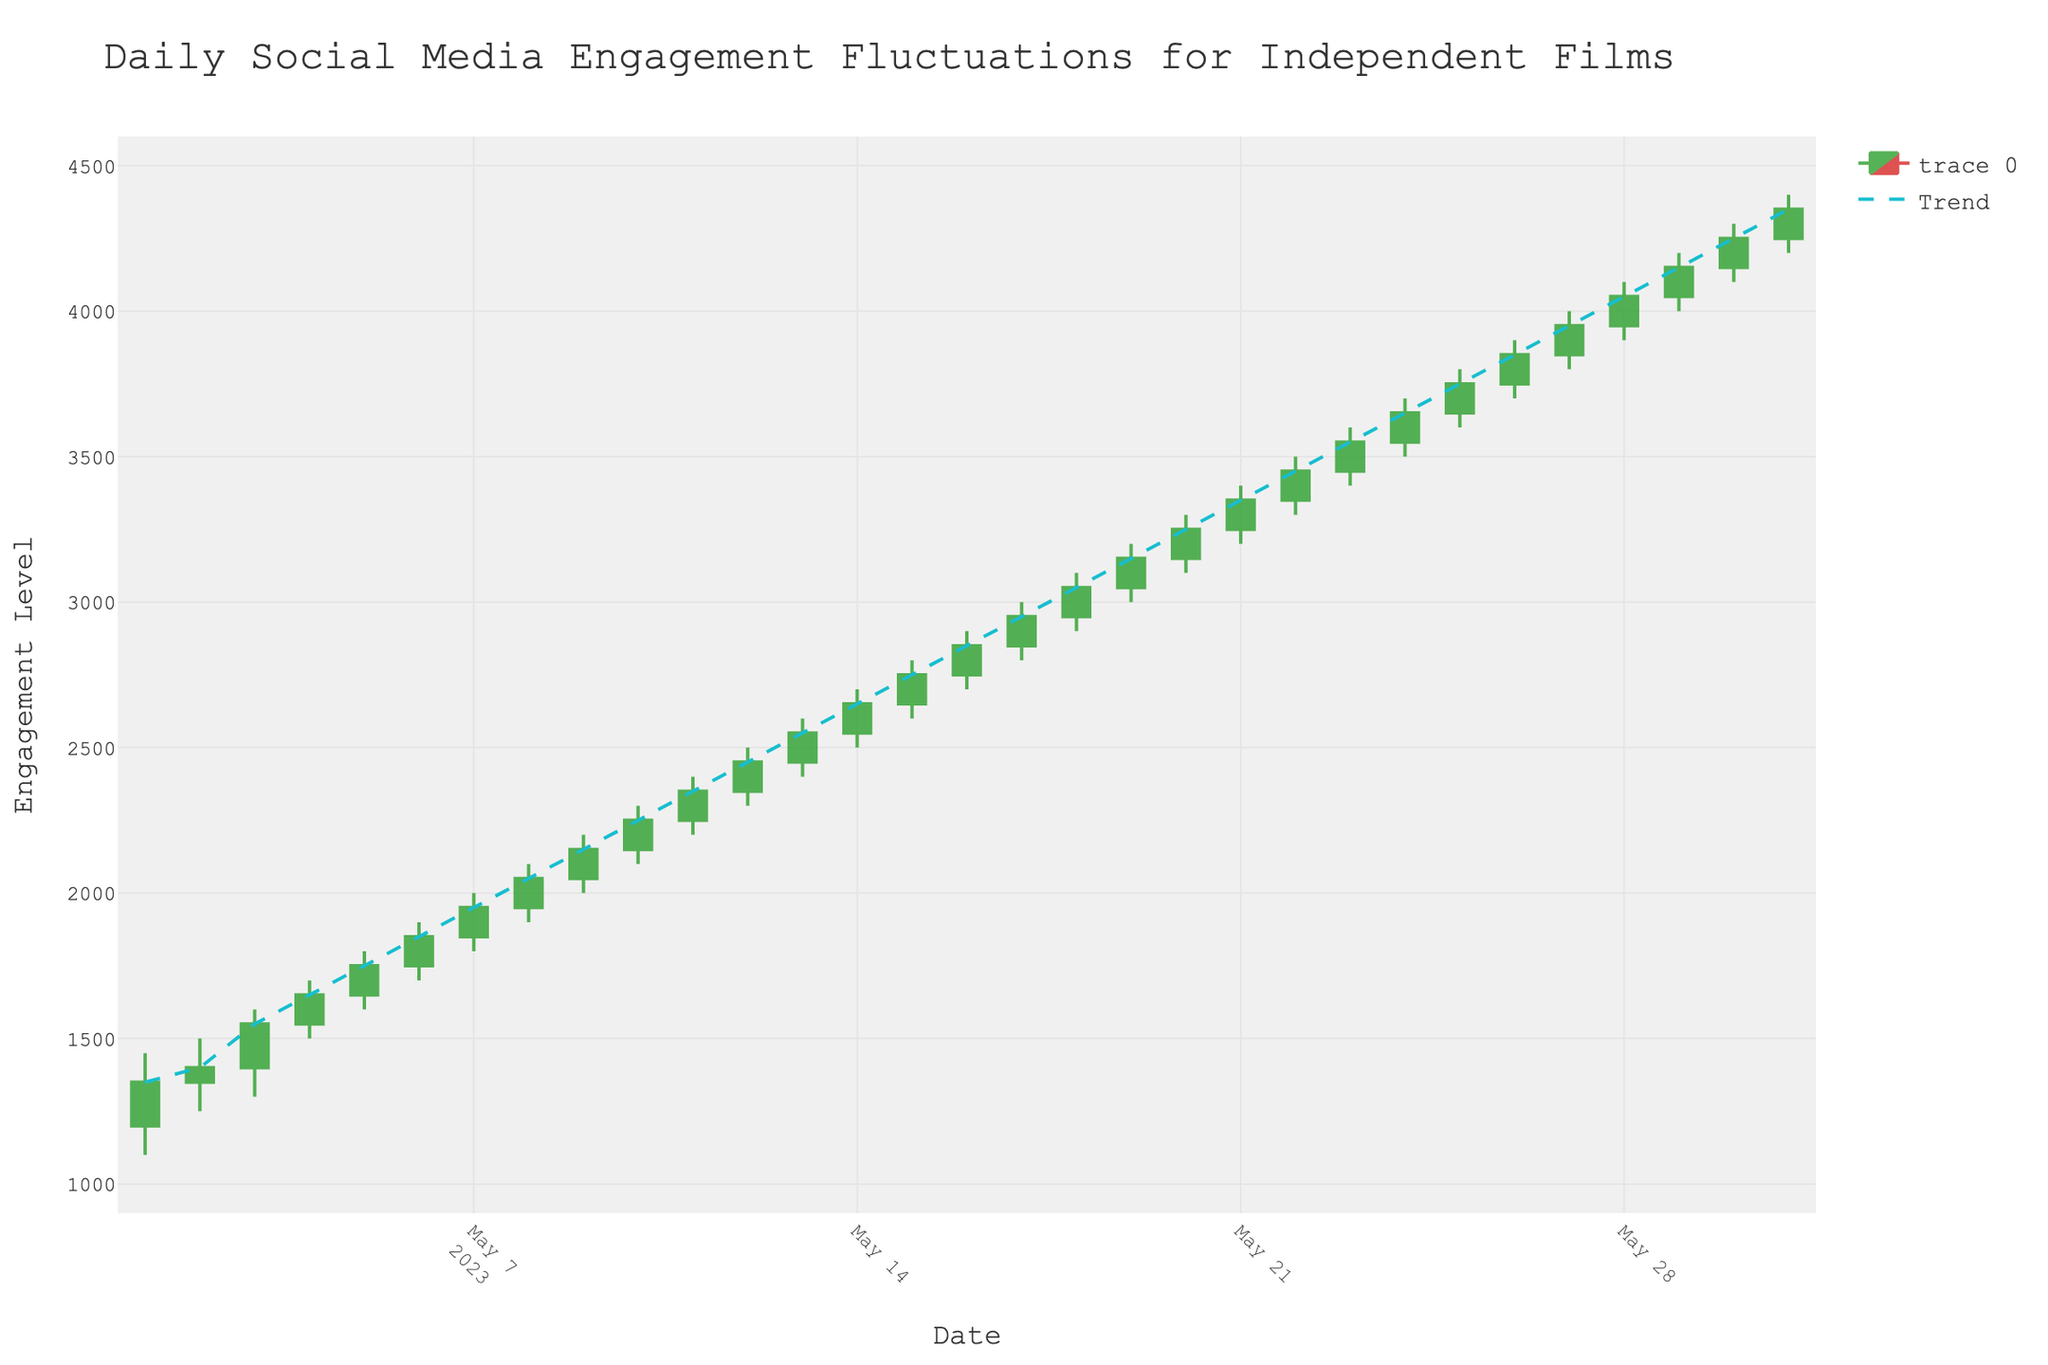What is the title of the chart? Look at the top of the chart where the title is displayed.
Answer: Daily Social Media Engagement Fluctuations for Independent Films What are the labels for the x-axis and y-axis? Check the text next to the axes. The x-axis label is at the bottom, and the y-axis label is on the left side.
Answer: x-axis: Date, y-axis: Engagement Level On which date does the highest 'High' value occur? Find the tallest green or red candlestick and check the date associated with it. The highest 'High' value is on the last candlestick.
Answer: 2023-05-31 What is the trend displayed in the chart? Look for the trendline, which is a dashed line running through the candlesticks. The trend generally shows the overall direction of the data.
Answer: Increasing trend What's the range of engagement levels displayed on the y-axis? Check the minimum and maximum numbers on the y-axis. These values indicate the range.
Answer: 900 to 4600 What are the opening and closing engagement levels on May 10th? Find the candlestick for May 10th. The 'Open' level is the bottom of the thick line for green candlesticks, and the top for red. The 'Close' level is the top of the thick line for green and the bottom for red.
Answer: Open: 2150, Close: 2250 Which day had the largest difference between 'High' and 'Low' engagement levels? Calculate the difference (High - Low) for each day and find the day with the largest value.
Answer: 2023-05-31 (4400 - 4200 = 200) Compare the 'Open' value on May 1st with the 'Close' value on May 31st. Which is higher? Look at the 'Open' on May 1st and 'Close' on May 31st and compare the two values.
Answer: 'Close' on May 31st is higher (4350 vs 1200) How many days had a higher 'Close' than 'Open' value? Count the number of green candlesticks, as they represent days where 'Close' is higher than 'Open'.
Answer: 31 days 